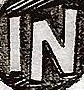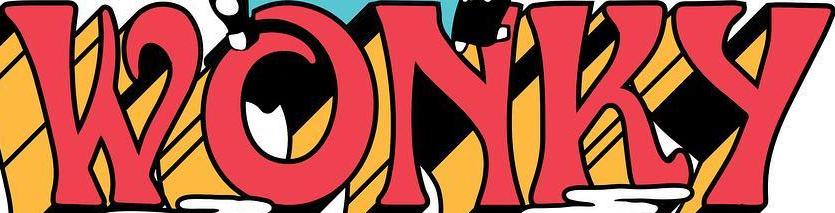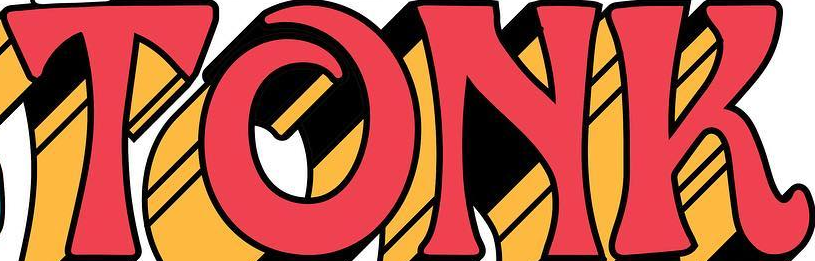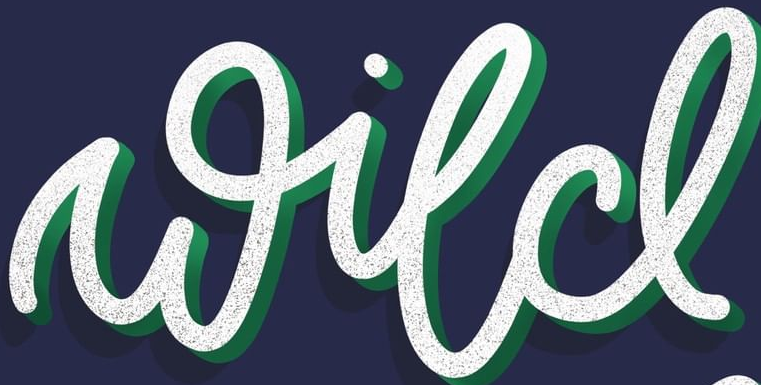Read the text from these images in sequence, separated by a semicolon. IN; WONKY; TONK; wild 